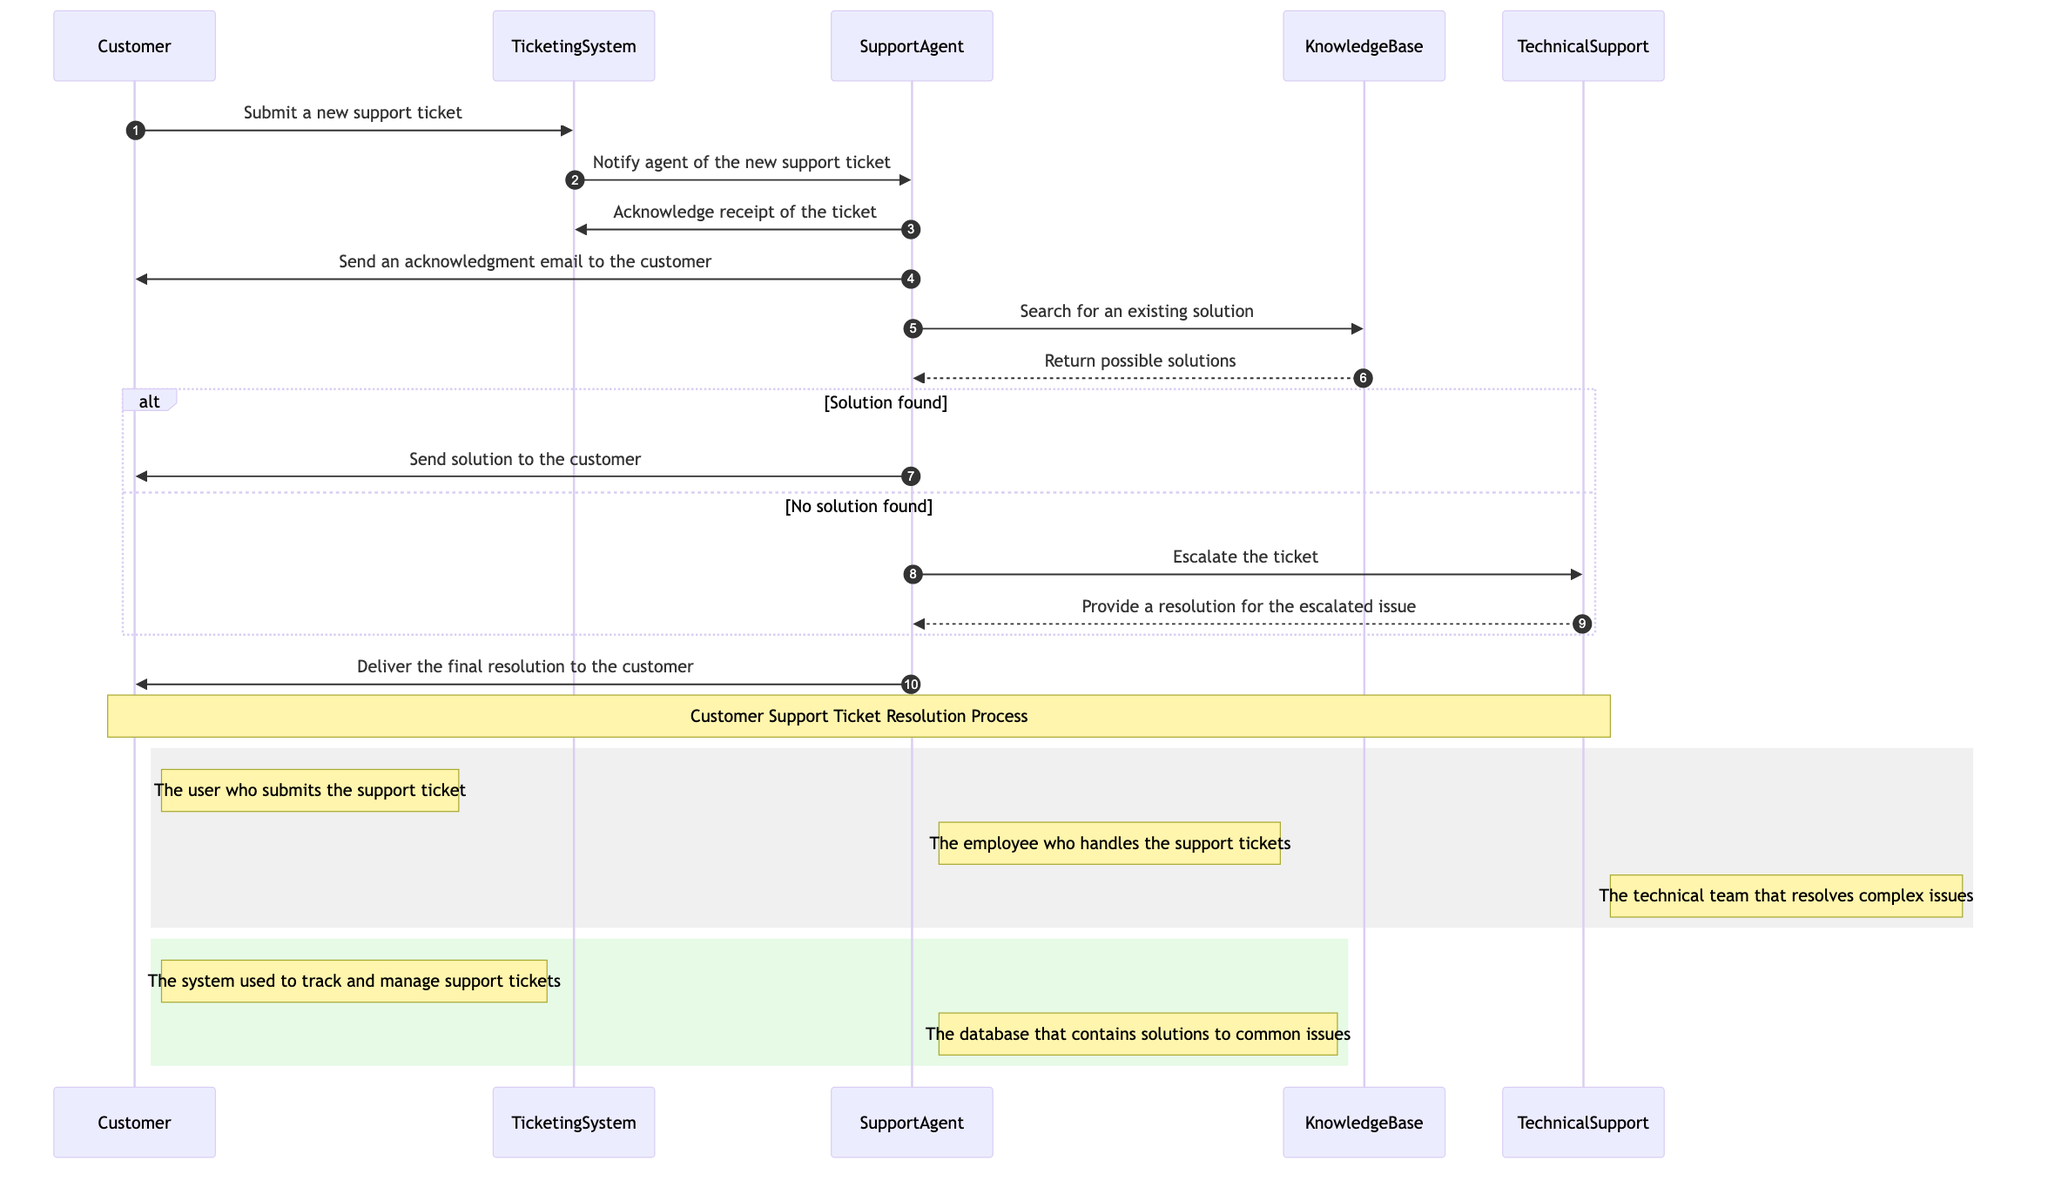What is the first action taken by the Customer? The first action in the sequence diagram is the Customer submitting a new support ticket to the Ticketing System. This is the starting point of the interaction as depicted in the diagram.
Answer: Submit a new support ticket How many actors are involved in the process? The diagram lists three actors: Customer, SupportAgent, and TechnicalSupport. Counting these actors gives us a total of three participants involved in the support ticket resolution process.
Answer: 3 What message is sent from the Ticketing System to the Support Agent? The diagram shows that after the Customer submits a ticket, the Ticketing System sends a notification to the Support Agent about the new support ticket. This message is represented in the flow of the sequence diagram.
Answer: Notify agent of the new support ticket What does the Support Agent do if a solution is found? According to the diagram, if the Support Agent finds a solution in the Knowledge Base, they send that solution to the Customer. This is indicated as a direct action following the retrieval of possible solutions.
Answer: Send solution to the customer What is the outcome if no solution is found? If no solution is found, the Support Agent escalates the ticket to the Technical Support team. This is a conditional branch in the sequence of actions depicted in the diagram.
Answer: Escalate the ticket Which entity is used to track and manage support tickets? The Ticketing System is specifically identified in the diagram as the entity that tracks and manages support tickets. This entity plays a crucial role in the entire process, as shown through the interactions.
Answer: Ticketing System What happens after Technical Support provides a resolution? After the Technical Support team provides a resolution for the escalated issue, the Support Agent subsequently delivers that final resolution to the Customer, completing the resolution process outlined in the diagram.
Answer: Deliver the final resolution to the customer What database does the Support Agent interact with? The Support Agent interacts with the Knowledge Base in search for existing solutions. This entity is part of the ticket resolution process as shown in the sequence diagram.
Answer: Knowledge Base What is the role of the Customer in this process? The role of the Customer is to submit the support ticket to initiate the ticket resolution process. This action is represented as the first step in the sequence diagram.
Answer: Submit the support ticket 